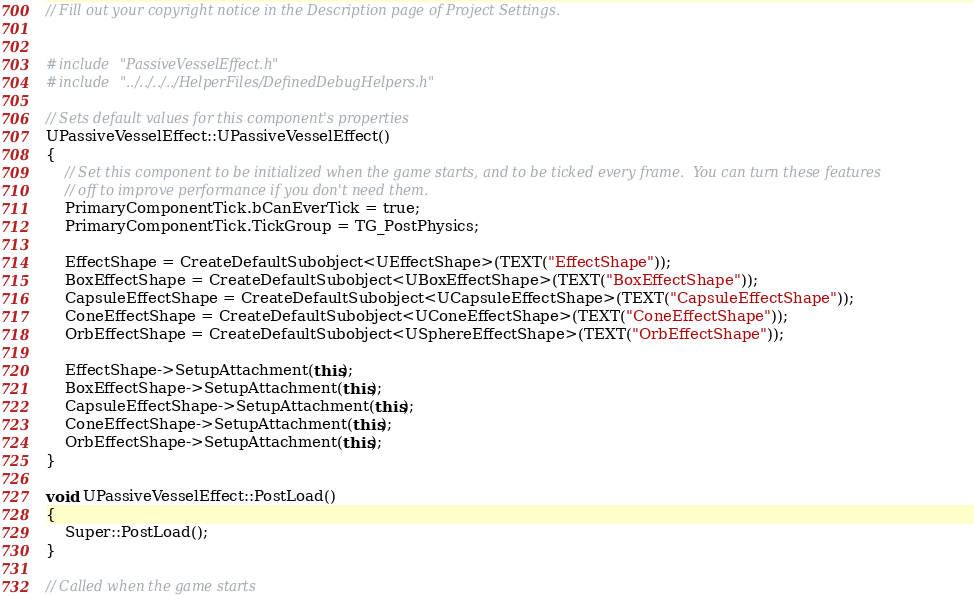Convert code to text. <code><loc_0><loc_0><loc_500><loc_500><_C++_>// Fill out your copyright notice in the Description page of Project Settings.


#include "PassiveVesselEffect.h"
#include "../../../../HelperFiles/DefinedDebugHelpers.h"

// Sets default values for this component's properties
UPassiveVesselEffect::UPassiveVesselEffect()
{
	// Set this component to be initialized when the game starts, and to be ticked every frame.  You can turn these features
	// off to improve performance if you don't need them.
	PrimaryComponentTick.bCanEverTick = true;
	PrimaryComponentTick.TickGroup = TG_PostPhysics;

	EffectShape = CreateDefaultSubobject<UEffectShape>(TEXT("EffectShape"));
	BoxEffectShape = CreateDefaultSubobject<UBoxEffectShape>(TEXT("BoxEffectShape"));
	CapsuleEffectShape = CreateDefaultSubobject<UCapsuleEffectShape>(TEXT("CapsuleEffectShape"));
	ConeEffectShape = CreateDefaultSubobject<UConeEffectShape>(TEXT("ConeEffectShape"));
	OrbEffectShape = CreateDefaultSubobject<USphereEffectShape>(TEXT("OrbEffectShape"));
	
	EffectShape->SetupAttachment(this);
	BoxEffectShape->SetupAttachment(this);
	CapsuleEffectShape->SetupAttachment(this);
	ConeEffectShape->SetupAttachment(this);
	OrbEffectShape->SetupAttachment(this);
}

void UPassiveVesselEffect::PostLoad()
{
	Super::PostLoad();
}

// Called when the game starts</code> 